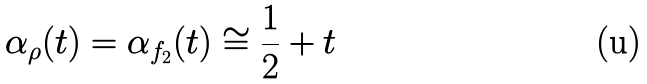Convert formula to latex. <formula><loc_0><loc_0><loc_500><loc_500>\alpha _ { \rho } ( t ) = \alpha _ { f _ { 2 } } ( t ) \cong \frac { 1 } { 2 } + t</formula> 